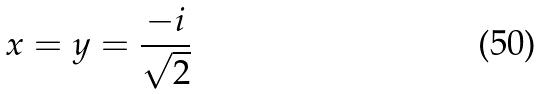Convert formula to latex. <formula><loc_0><loc_0><loc_500><loc_500>x = y = \frac { - i } { \sqrt { 2 } }</formula> 